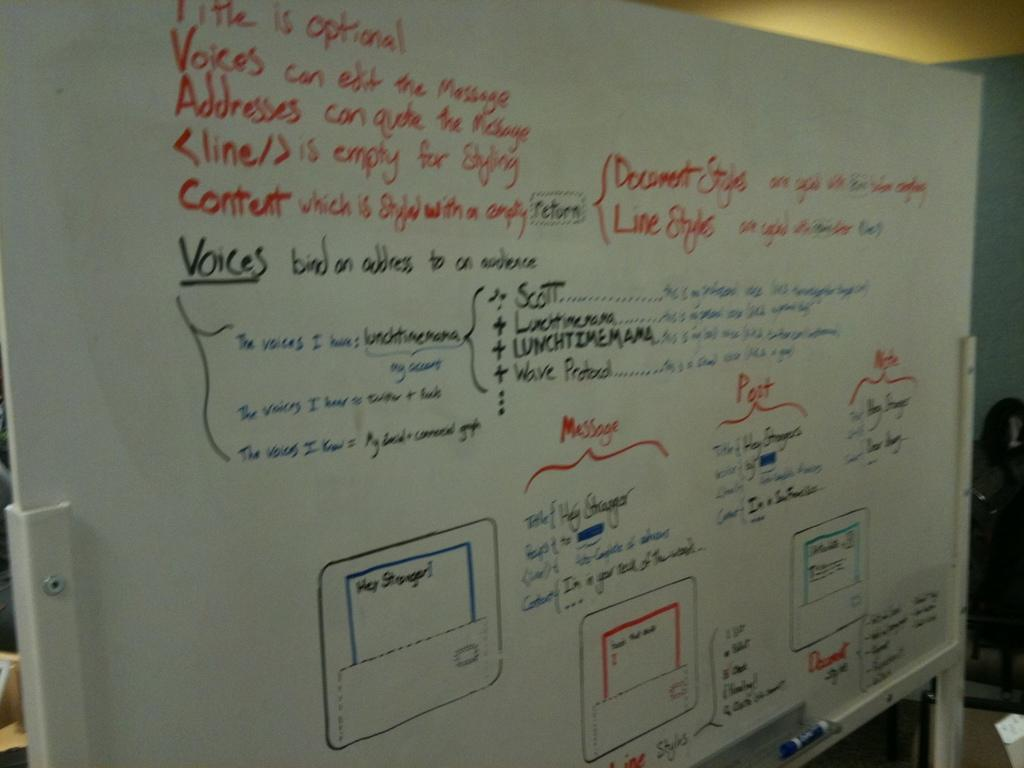<image>
Render a clear and concise summary of the photo. The white board has a flowchart for sending messages and instructions on styling. 